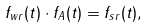<formula> <loc_0><loc_0><loc_500><loc_500>f _ { w r } ( t ) \cdot f _ { A } ( t ) = f _ { s r } ( t ) ,</formula> 